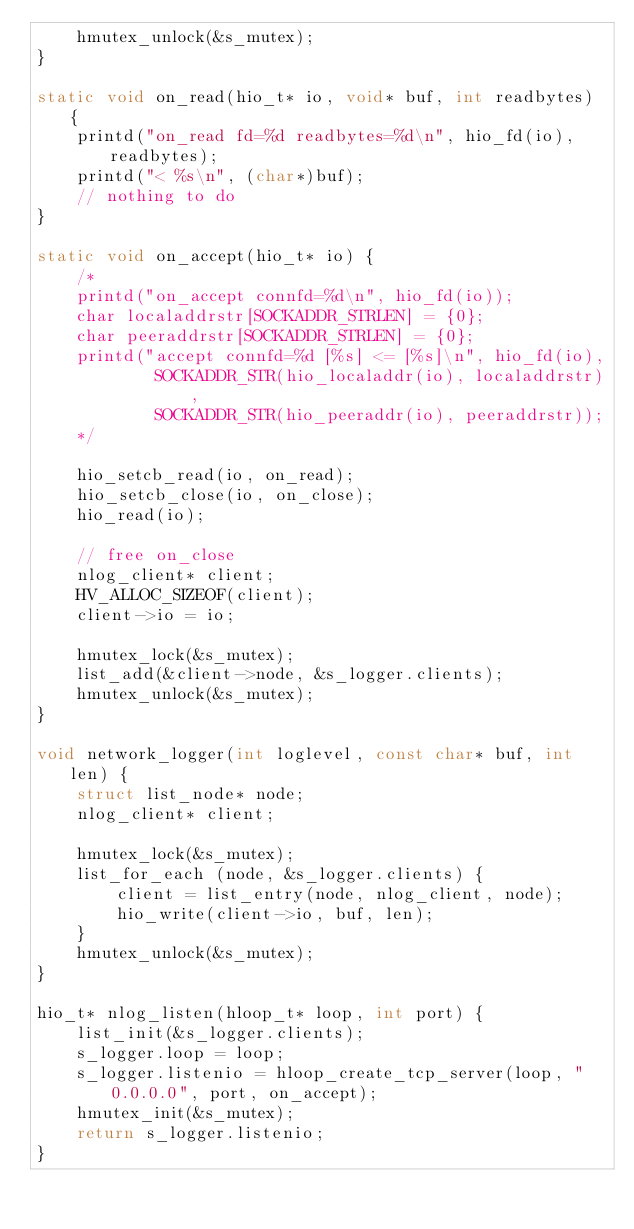<code> <loc_0><loc_0><loc_500><loc_500><_C_>    hmutex_unlock(&s_mutex);
}

static void on_read(hio_t* io, void* buf, int readbytes) {
    printd("on_read fd=%d readbytes=%d\n", hio_fd(io), readbytes);
    printd("< %s\n", (char*)buf);
    // nothing to do
}

static void on_accept(hio_t* io) {
    /*
    printd("on_accept connfd=%d\n", hio_fd(io));
    char localaddrstr[SOCKADDR_STRLEN] = {0};
    char peeraddrstr[SOCKADDR_STRLEN] = {0};
    printd("accept connfd=%d [%s] <= [%s]\n", hio_fd(io),
            SOCKADDR_STR(hio_localaddr(io), localaddrstr),
            SOCKADDR_STR(hio_peeraddr(io), peeraddrstr));
    */

    hio_setcb_read(io, on_read);
    hio_setcb_close(io, on_close);
    hio_read(io);

    // free on_close
    nlog_client* client;
    HV_ALLOC_SIZEOF(client);
    client->io = io;

    hmutex_lock(&s_mutex);
    list_add(&client->node, &s_logger.clients);
    hmutex_unlock(&s_mutex);
}

void network_logger(int loglevel, const char* buf, int len) {
    struct list_node* node;
    nlog_client* client;

    hmutex_lock(&s_mutex);
    list_for_each (node, &s_logger.clients) {
        client = list_entry(node, nlog_client, node);
        hio_write(client->io, buf, len);
    }
    hmutex_unlock(&s_mutex);
}

hio_t* nlog_listen(hloop_t* loop, int port) {
    list_init(&s_logger.clients);
    s_logger.loop = loop;
    s_logger.listenio = hloop_create_tcp_server(loop, "0.0.0.0", port, on_accept);
    hmutex_init(&s_mutex);
    return s_logger.listenio;
}
</code> 